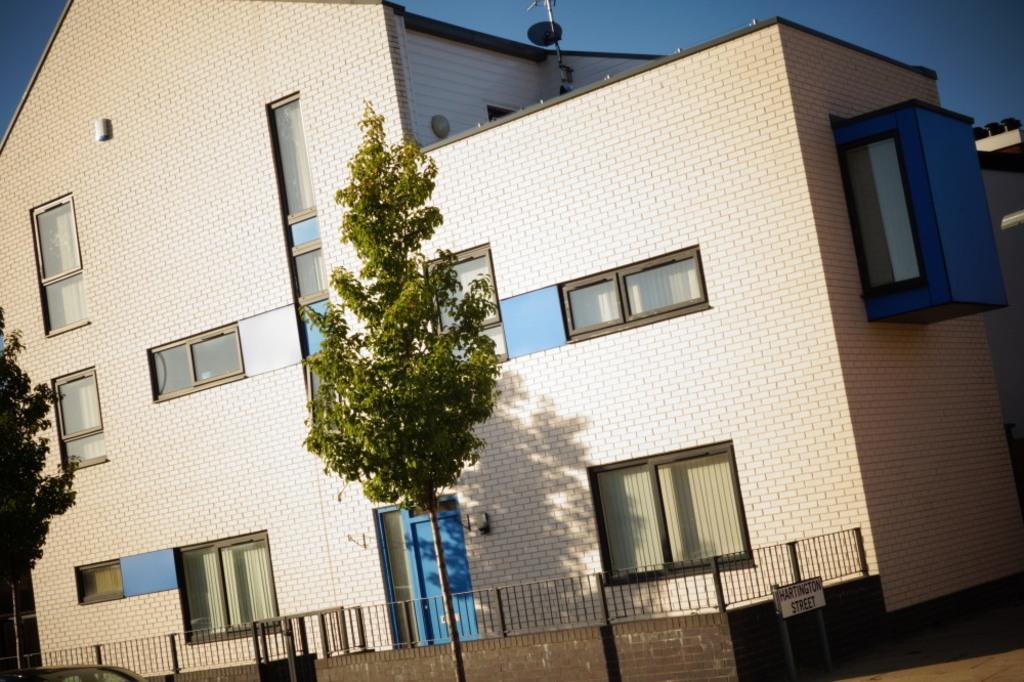How would you summarize this image in a sentence or two? In the image there is a building with brick wall and a window,curtains and middle we can also see trees and sky is on top. 